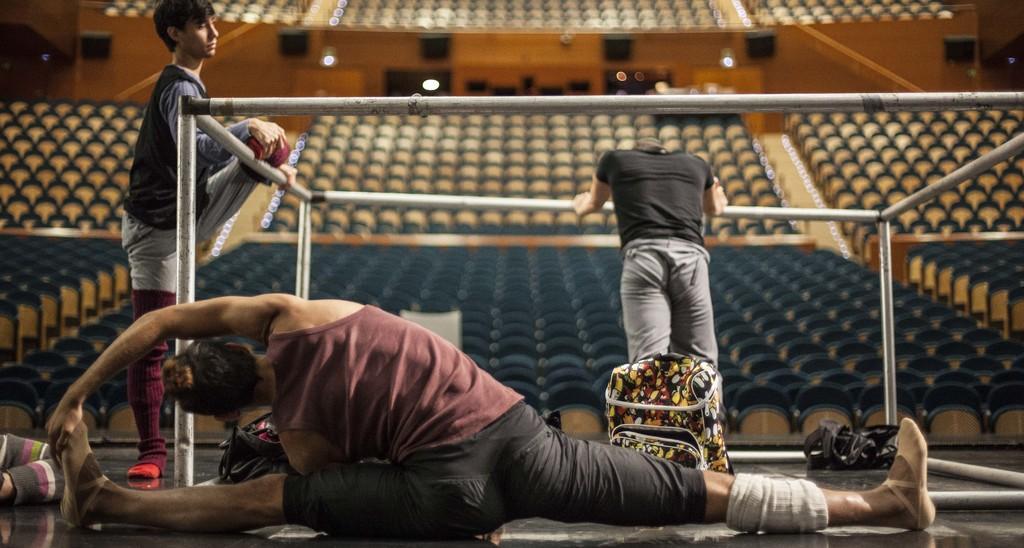Could you give a brief overview of what you see in this image? In this picture we can see a person stretching body on the floor. There are bags on the floor. We can see a few poles. There are many chairs and lights in the background. 